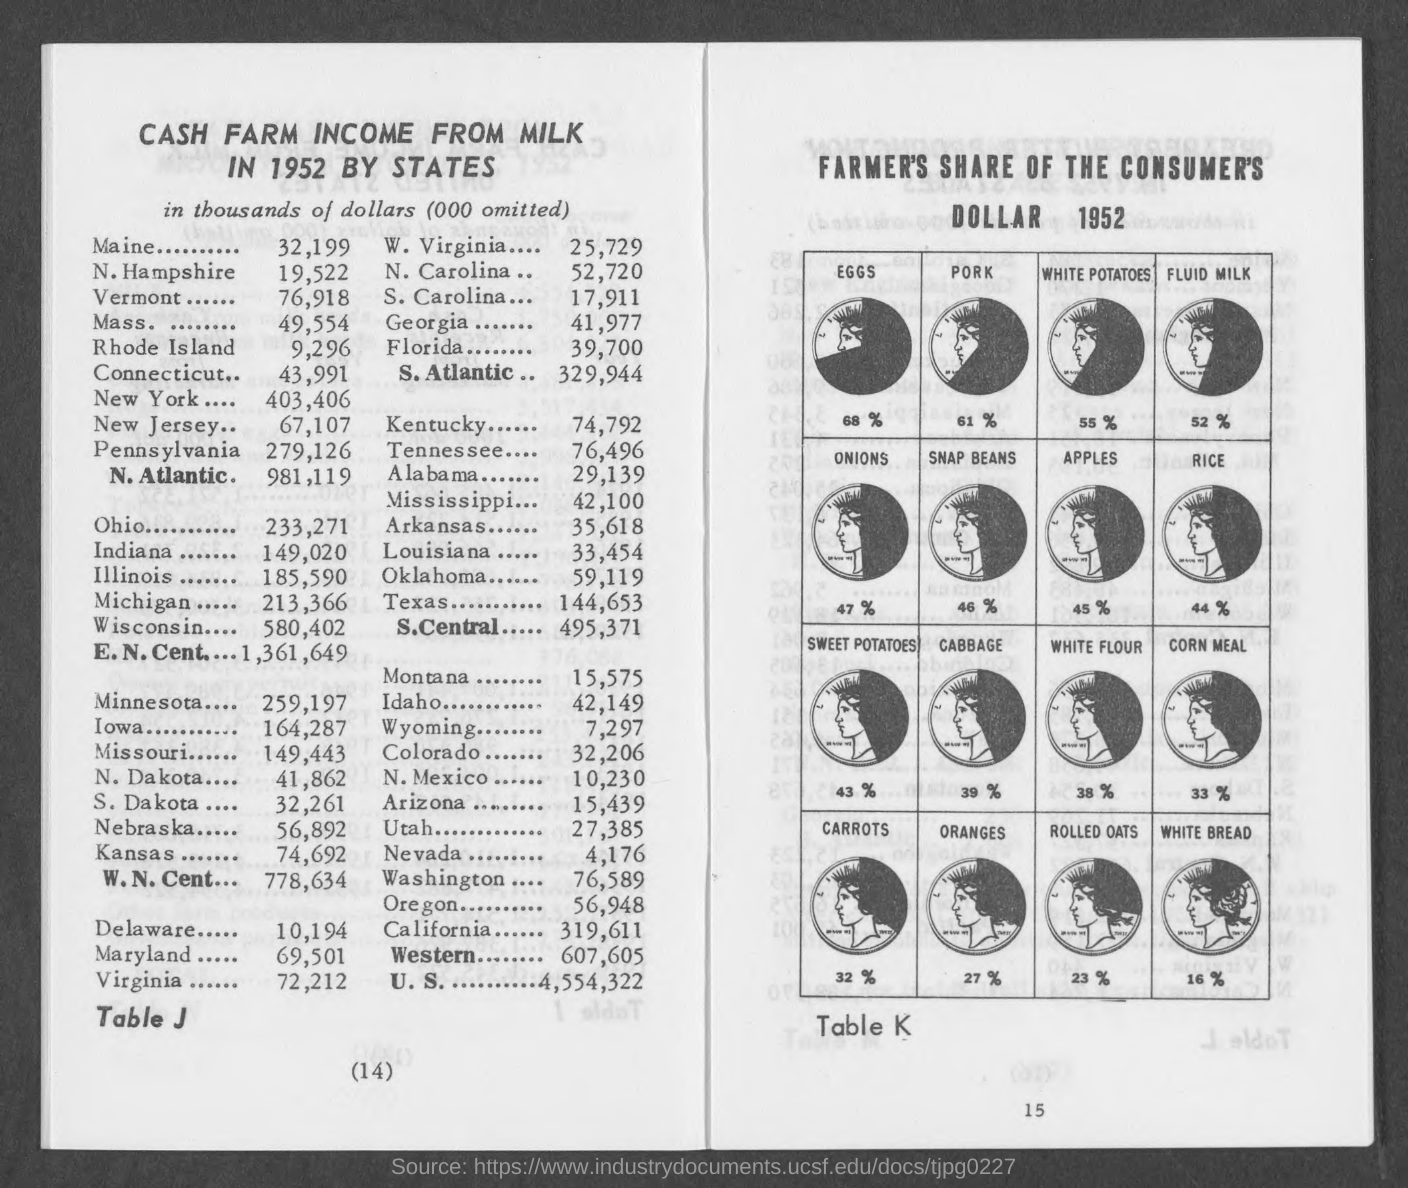What is the Cash Farm income from milk in 1952 in Maine?
Give a very brief answer. 32,199. What is the Cash Farm income from milk in 1952 in N.Hampshire?
Make the answer very short. 19,522. What is the Cash Farm income from milk in 1952 in Mass.?
Provide a succinct answer. 49,554. What is the Cash Farm income from milk in 1952 in New York?
Your answer should be very brief. 403,406. What is the Cash Farm income from milk in 1952 in New Jersey?
Offer a terse response. 67,107. What is the Cash Farm income from milk in 1952 in Ohio?
Ensure brevity in your answer.  233,271. What is the Cash Farm income from milk in 1952 in Indiana?
Provide a succinct answer. 149,020. What is the Cash Farm income from milk in 1952 in Ilinois?
Your answer should be very brief. 185,590. What is the Cash Farm income from milk in 1952 in Michigan?
Provide a succinct answer. 213,366. 